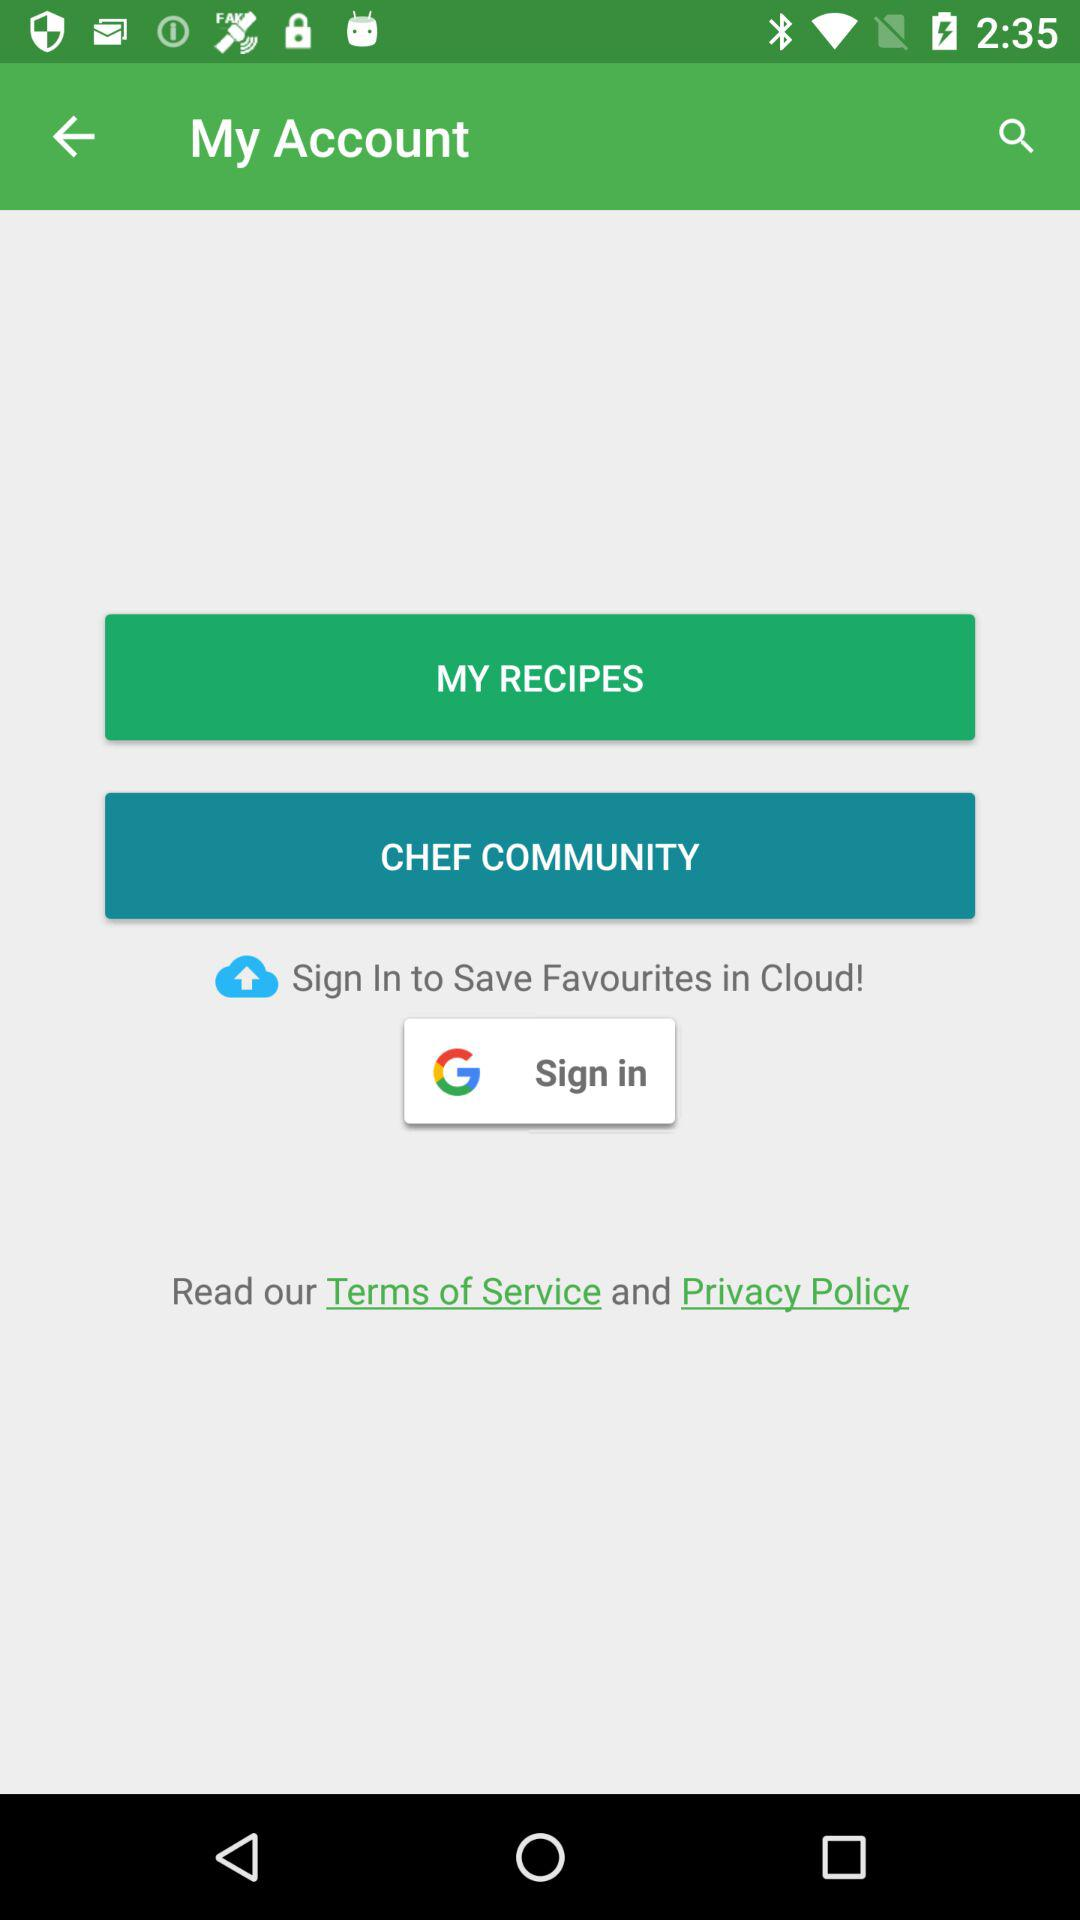What application can we use to sign in? You can use "Google" to sign in. 